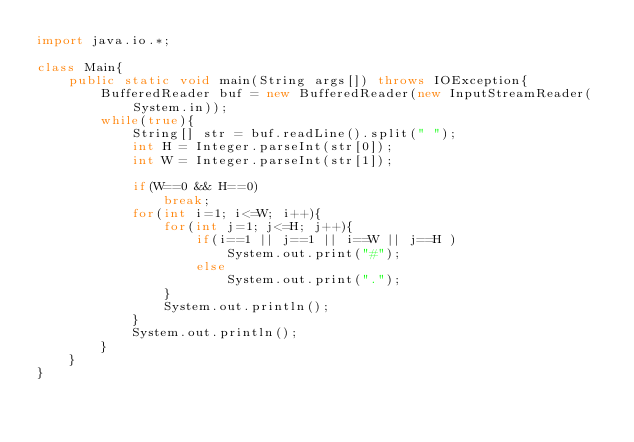Convert code to text. <code><loc_0><loc_0><loc_500><loc_500><_Java_>import java.io.*;

class Main{
	public static void main(String args[]) throws IOException{
		BufferedReader buf = new BufferedReader(new InputStreamReader(System.in));
		while(true){
			String[] str = buf.readLine().split(" ");
			int H = Integer.parseInt(str[0]);
			int W = Integer.parseInt(str[1]);

			if(W==0 && H==0)
				break;
			for(int i=1; i<=W; i++){
				for(int j=1; j<=H; j++){
					if(i==1 || j==1 || i==W || j==H )
						System.out.print("#");
					else
						System.out.print(".");
				}
				System.out.println();
			}
			System.out.println();
		}		
	}
}</code> 